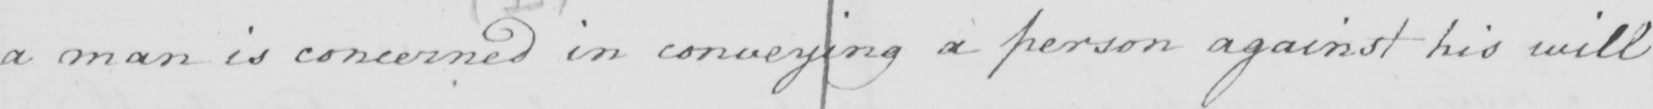Transcribe the text shown in this historical manuscript line. a man is concerned in conveying a person against his will 